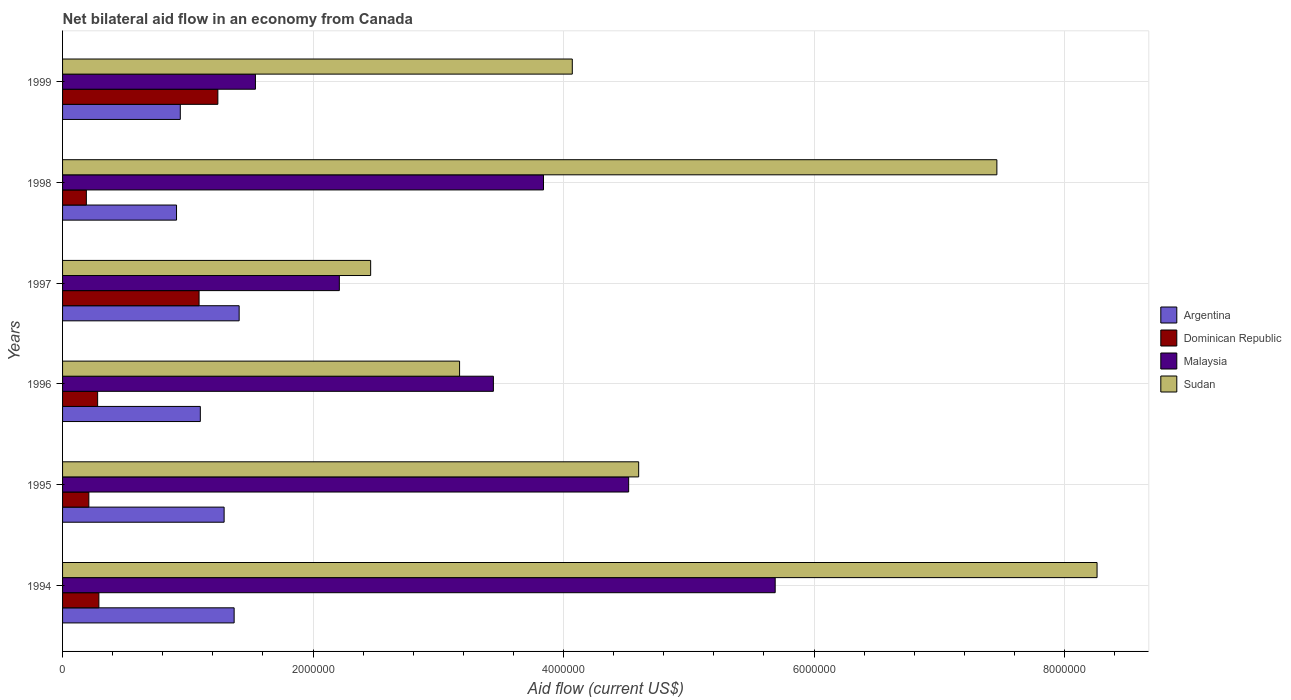How many different coloured bars are there?
Ensure brevity in your answer.  4. How many groups of bars are there?
Provide a succinct answer. 6. Are the number of bars per tick equal to the number of legend labels?
Provide a short and direct response. Yes. What is the label of the 1st group of bars from the top?
Offer a very short reply. 1999. In how many cases, is the number of bars for a given year not equal to the number of legend labels?
Your answer should be very brief. 0. What is the net bilateral aid flow in Malaysia in 1997?
Keep it short and to the point. 2.21e+06. Across all years, what is the maximum net bilateral aid flow in Sudan?
Offer a terse response. 8.26e+06. Across all years, what is the minimum net bilateral aid flow in Argentina?
Your response must be concise. 9.10e+05. What is the total net bilateral aid flow in Argentina in the graph?
Keep it short and to the point. 7.02e+06. What is the difference between the net bilateral aid flow in Malaysia in 1996 and the net bilateral aid flow in Argentina in 1998?
Offer a terse response. 2.53e+06. What is the average net bilateral aid flow in Argentina per year?
Your answer should be very brief. 1.17e+06. In the year 1998, what is the difference between the net bilateral aid flow in Dominican Republic and net bilateral aid flow in Malaysia?
Your answer should be compact. -3.65e+06. In how many years, is the net bilateral aid flow in Sudan greater than 7200000 US$?
Give a very brief answer. 2. What is the ratio of the net bilateral aid flow in Malaysia in 1994 to that in 1998?
Provide a succinct answer. 1.48. What is the difference between the highest and the lowest net bilateral aid flow in Sudan?
Provide a short and direct response. 5.80e+06. Is it the case that in every year, the sum of the net bilateral aid flow in Sudan and net bilateral aid flow in Argentina is greater than the sum of net bilateral aid flow in Malaysia and net bilateral aid flow in Dominican Republic?
Make the answer very short. No. What does the 3rd bar from the top in 1996 represents?
Your response must be concise. Dominican Republic. What does the 2nd bar from the bottom in 1997 represents?
Provide a succinct answer. Dominican Republic. Is it the case that in every year, the sum of the net bilateral aid flow in Sudan and net bilateral aid flow in Dominican Republic is greater than the net bilateral aid flow in Argentina?
Give a very brief answer. Yes. How many bars are there?
Make the answer very short. 24. How many years are there in the graph?
Provide a short and direct response. 6. Does the graph contain any zero values?
Your answer should be very brief. No. How many legend labels are there?
Your answer should be very brief. 4. What is the title of the graph?
Your answer should be very brief. Net bilateral aid flow in an economy from Canada. Does "South Africa" appear as one of the legend labels in the graph?
Ensure brevity in your answer.  No. What is the label or title of the X-axis?
Give a very brief answer. Aid flow (current US$). What is the Aid flow (current US$) in Argentina in 1994?
Your answer should be compact. 1.37e+06. What is the Aid flow (current US$) of Dominican Republic in 1994?
Your answer should be very brief. 2.90e+05. What is the Aid flow (current US$) of Malaysia in 1994?
Offer a very short reply. 5.69e+06. What is the Aid flow (current US$) of Sudan in 1994?
Ensure brevity in your answer.  8.26e+06. What is the Aid flow (current US$) in Argentina in 1995?
Give a very brief answer. 1.29e+06. What is the Aid flow (current US$) of Dominican Republic in 1995?
Offer a terse response. 2.10e+05. What is the Aid flow (current US$) in Malaysia in 1995?
Make the answer very short. 4.52e+06. What is the Aid flow (current US$) of Sudan in 1995?
Ensure brevity in your answer.  4.60e+06. What is the Aid flow (current US$) in Argentina in 1996?
Your response must be concise. 1.10e+06. What is the Aid flow (current US$) of Malaysia in 1996?
Your answer should be very brief. 3.44e+06. What is the Aid flow (current US$) of Sudan in 1996?
Your answer should be very brief. 3.17e+06. What is the Aid flow (current US$) in Argentina in 1997?
Your answer should be compact. 1.41e+06. What is the Aid flow (current US$) in Dominican Republic in 1997?
Your answer should be very brief. 1.09e+06. What is the Aid flow (current US$) in Malaysia in 1997?
Ensure brevity in your answer.  2.21e+06. What is the Aid flow (current US$) of Sudan in 1997?
Your response must be concise. 2.46e+06. What is the Aid flow (current US$) of Argentina in 1998?
Your answer should be compact. 9.10e+05. What is the Aid flow (current US$) in Dominican Republic in 1998?
Your response must be concise. 1.90e+05. What is the Aid flow (current US$) of Malaysia in 1998?
Your response must be concise. 3.84e+06. What is the Aid flow (current US$) of Sudan in 1998?
Keep it short and to the point. 7.46e+06. What is the Aid flow (current US$) in Argentina in 1999?
Keep it short and to the point. 9.40e+05. What is the Aid flow (current US$) of Dominican Republic in 1999?
Your answer should be compact. 1.24e+06. What is the Aid flow (current US$) of Malaysia in 1999?
Provide a succinct answer. 1.54e+06. What is the Aid flow (current US$) in Sudan in 1999?
Give a very brief answer. 4.07e+06. Across all years, what is the maximum Aid flow (current US$) in Argentina?
Give a very brief answer. 1.41e+06. Across all years, what is the maximum Aid flow (current US$) in Dominican Republic?
Provide a short and direct response. 1.24e+06. Across all years, what is the maximum Aid flow (current US$) in Malaysia?
Offer a very short reply. 5.69e+06. Across all years, what is the maximum Aid flow (current US$) in Sudan?
Offer a very short reply. 8.26e+06. Across all years, what is the minimum Aid flow (current US$) of Argentina?
Provide a short and direct response. 9.10e+05. Across all years, what is the minimum Aid flow (current US$) of Malaysia?
Keep it short and to the point. 1.54e+06. Across all years, what is the minimum Aid flow (current US$) in Sudan?
Ensure brevity in your answer.  2.46e+06. What is the total Aid flow (current US$) of Argentina in the graph?
Your answer should be very brief. 7.02e+06. What is the total Aid flow (current US$) of Dominican Republic in the graph?
Provide a short and direct response. 3.30e+06. What is the total Aid flow (current US$) of Malaysia in the graph?
Ensure brevity in your answer.  2.12e+07. What is the total Aid flow (current US$) of Sudan in the graph?
Your answer should be very brief. 3.00e+07. What is the difference between the Aid flow (current US$) in Argentina in 1994 and that in 1995?
Your answer should be compact. 8.00e+04. What is the difference between the Aid flow (current US$) of Dominican Republic in 1994 and that in 1995?
Provide a short and direct response. 8.00e+04. What is the difference between the Aid flow (current US$) in Malaysia in 1994 and that in 1995?
Provide a succinct answer. 1.17e+06. What is the difference between the Aid flow (current US$) in Sudan in 1994 and that in 1995?
Ensure brevity in your answer.  3.66e+06. What is the difference between the Aid flow (current US$) of Malaysia in 1994 and that in 1996?
Your answer should be compact. 2.25e+06. What is the difference between the Aid flow (current US$) in Sudan in 1994 and that in 1996?
Your response must be concise. 5.09e+06. What is the difference between the Aid flow (current US$) of Dominican Republic in 1994 and that in 1997?
Offer a very short reply. -8.00e+05. What is the difference between the Aid flow (current US$) in Malaysia in 1994 and that in 1997?
Your answer should be compact. 3.48e+06. What is the difference between the Aid flow (current US$) of Sudan in 1994 and that in 1997?
Offer a terse response. 5.80e+06. What is the difference between the Aid flow (current US$) of Malaysia in 1994 and that in 1998?
Your response must be concise. 1.85e+06. What is the difference between the Aid flow (current US$) in Sudan in 1994 and that in 1998?
Keep it short and to the point. 8.00e+05. What is the difference between the Aid flow (current US$) in Argentina in 1994 and that in 1999?
Your response must be concise. 4.30e+05. What is the difference between the Aid flow (current US$) in Dominican Republic in 1994 and that in 1999?
Give a very brief answer. -9.50e+05. What is the difference between the Aid flow (current US$) in Malaysia in 1994 and that in 1999?
Your response must be concise. 4.15e+06. What is the difference between the Aid flow (current US$) in Sudan in 1994 and that in 1999?
Keep it short and to the point. 4.19e+06. What is the difference between the Aid flow (current US$) in Dominican Republic in 1995 and that in 1996?
Your response must be concise. -7.00e+04. What is the difference between the Aid flow (current US$) in Malaysia in 1995 and that in 1996?
Provide a short and direct response. 1.08e+06. What is the difference between the Aid flow (current US$) in Sudan in 1995 and that in 1996?
Keep it short and to the point. 1.43e+06. What is the difference between the Aid flow (current US$) in Dominican Republic in 1995 and that in 1997?
Your answer should be compact. -8.80e+05. What is the difference between the Aid flow (current US$) in Malaysia in 1995 and that in 1997?
Make the answer very short. 2.31e+06. What is the difference between the Aid flow (current US$) in Sudan in 1995 and that in 1997?
Your response must be concise. 2.14e+06. What is the difference between the Aid flow (current US$) of Dominican Republic in 1995 and that in 1998?
Your answer should be very brief. 2.00e+04. What is the difference between the Aid flow (current US$) in Malaysia in 1995 and that in 1998?
Give a very brief answer. 6.80e+05. What is the difference between the Aid flow (current US$) of Sudan in 1995 and that in 1998?
Offer a terse response. -2.86e+06. What is the difference between the Aid flow (current US$) of Dominican Republic in 1995 and that in 1999?
Ensure brevity in your answer.  -1.03e+06. What is the difference between the Aid flow (current US$) in Malaysia in 1995 and that in 1999?
Provide a short and direct response. 2.98e+06. What is the difference between the Aid flow (current US$) in Sudan in 1995 and that in 1999?
Make the answer very short. 5.30e+05. What is the difference between the Aid flow (current US$) in Argentina in 1996 and that in 1997?
Make the answer very short. -3.10e+05. What is the difference between the Aid flow (current US$) in Dominican Republic in 1996 and that in 1997?
Your response must be concise. -8.10e+05. What is the difference between the Aid flow (current US$) of Malaysia in 1996 and that in 1997?
Ensure brevity in your answer.  1.23e+06. What is the difference between the Aid flow (current US$) of Sudan in 1996 and that in 1997?
Your answer should be very brief. 7.10e+05. What is the difference between the Aid flow (current US$) of Argentina in 1996 and that in 1998?
Make the answer very short. 1.90e+05. What is the difference between the Aid flow (current US$) in Malaysia in 1996 and that in 1998?
Your answer should be very brief. -4.00e+05. What is the difference between the Aid flow (current US$) in Sudan in 1996 and that in 1998?
Your answer should be compact. -4.29e+06. What is the difference between the Aid flow (current US$) of Argentina in 1996 and that in 1999?
Offer a very short reply. 1.60e+05. What is the difference between the Aid flow (current US$) in Dominican Republic in 1996 and that in 1999?
Keep it short and to the point. -9.60e+05. What is the difference between the Aid flow (current US$) in Malaysia in 1996 and that in 1999?
Keep it short and to the point. 1.90e+06. What is the difference between the Aid flow (current US$) of Sudan in 1996 and that in 1999?
Offer a terse response. -9.00e+05. What is the difference between the Aid flow (current US$) in Argentina in 1997 and that in 1998?
Your answer should be compact. 5.00e+05. What is the difference between the Aid flow (current US$) in Malaysia in 1997 and that in 1998?
Offer a terse response. -1.63e+06. What is the difference between the Aid flow (current US$) of Sudan in 1997 and that in 1998?
Make the answer very short. -5.00e+06. What is the difference between the Aid flow (current US$) in Malaysia in 1997 and that in 1999?
Keep it short and to the point. 6.70e+05. What is the difference between the Aid flow (current US$) in Sudan in 1997 and that in 1999?
Offer a terse response. -1.61e+06. What is the difference between the Aid flow (current US$) of Dominican Republic in 1998 and that in 1999?
Offer a terse response. -1.05e+06. What is the difference between the Aid flow (current US$) of Malaysia in 1998 and that in 1999?
Offer a terse response. 2.30e+06. What is the difference between the Aid flow (current US$) of Sudan in 1998 and that in 1999?
Your response must be concise. 3.39e+06. What is the difference between the Aid flow (current US$) in Argentina in 1994 and the Aid flow (current US$) in Dominican Republic in 1995?
Make the answer very short. 1.16e+06. What is the difference between the Aid flow (current US$) in Argentina in 1994 and the Aid flow (current US$) in Malaysia in 1995?
Your answer should be compact. -3.15e+06. What is the difference between the Aid flow (current US$) in Argentina in 1994 and the Aid flow (current US$) in Sudan in 1995?
Your answer should be very brief. -3.23e+06. What is the difference between the Aid flow (current US$) in Dominican Republic in 1994 and the Aid flow (current US$) in Malaysia in 1995?
Offer a terse response. -4.23e+06. What is the difference between the Aid flow (current US$) of Dominican Republic in 1994 and the Aid flow (current US$) of Sudan in 1995?
Your answer should be compact. -4.31e+06. What is the difference between the Aid flow (current US$) of Malaysia in 1994 and the Aid flow (current US$) of Sudan in 1995?
Provide a short and direct response. 1.09e+06. What is the difference between the Aid flow (current US$) of Argentina in 1994 and the Aid flow (current US$) of Dominican Republic in 1996?
Your answer should be very brief. 1.09e+06. What is the difference between the Aid flow (current US$) in Argentina in 1994 and the Aid flow (current US$) in Malaysia in 1996?
Your answer should be very brief. -2.07e+06. What is the difference between the Aid flow (current US$) of Argentina in 1994 and the Aid flow (current US$) of Sudan in 1996?
Your answer should be compact. -1.80e+06. What is the difference between the Aid flow (current US$) in Dominican Republic in 1994 and the Aid flow (current US$) in Malaysia in 1996?
Your answer should be compact. -3.15e+06. What is the difference between the Aid flow (current US$) in Dominican Republic in 1994 and the Aid flow (current US$) in Sudan in 1996?
Give a very brief answer. -2.88e+06. What is the difference between the Aid flow (current US$) in Malaysia in 1994 and the Aid flow (current US$) in Sudan in 1996?
Offer a terse response. 2.52e+06. What is the difference between the Aid flow (current US$) of Argentina in 1994 and the Aid flow (current US$) of Malaysia in 1997?
Make the answer very short. -8.40e+05. What is the difference between the Aid flow (current US$) in Argentina in 1994 and the Aid flow (current US$) in Sudan in 1997?
Ensure brevity in your answer.  -1.09e+06. What is the difference between the Aid flow (current US$) of Dominican Republic in 1994 and the Aid flow (current US$) of Malaysia in 1997?
Offer a terse response. -1.92e+06. What is the difference between the Aid flow (current US$) in Dominican Republic in 1994 and the Aid flow (current US$) in Sudan in 1997?
Your response must be concise. -2.17e+06. What is the difference between the Aid flow (current US$) of Malaysia in 1994 and the Aid flow (current US$) of Sudan in 1997?
Keep it short and to the point. 3.23e+06. What is the difference between the Aid flow (current US$) in Argentina in 1994 and the Aid flow (current US$) in Dominican Republic in 1998?
Provide a succinct answer. 1.18e+06. What is the difference between the Aid flow (current US$) of Argentina in 1994 and the Aid flow (current US$) of Malaysia in 1998?
Your answer should be very brief. -2.47e+06. What is the difference between the Aid flow (current US$) in Argentina in 1994 and the Aid flow (current US$) in Sudan in 1998?
Keep it short and to the point. -6.09e+06. What is the difference between the Aid flow (current US$) in Dominican Republic in 1994 and the Aid flow (current US$) in Malaysia in 1998?
Your answer should be very brief. -3.55e+06. What is the difference between the Aid flow (current US$) of Dominican Republic in 1994 and the Aid flow (current US$) of Sudan in 1998?
Keep it short and to the point. -7.17e+06. What is the difference between the Aid flow (current US$) of Malaysia in 1994 and the Aid flow (current US$) of Sudan in 1998?
Provide a succinct answer. -1.77e+06. What is the difference between the Aid flow (current US$) in Argentina in 1994 and the Aid flow (current US$) in Dominican Republic in 1999?
Your answer should be very brief. 1.30e+05. What is the difference between the Aid flow (current US$) in Argentina in 1994 and the Aid flow (current US$) in Malaysia in 1999?
Your answer should be very brief. -1.70e+05. What is the difference between the Aid flow (current US$) of Argentina in 1994 and the Aid flow (current US$) of Sudan in 1999?
Offer a very short reply. -2.70e+06. What is the difference between the Aid flow (current US$) of Dominican Republic in 1994 and the Aid flow (current US$) of Malaysia in 1999?
Keep it short and to the point. -1.25e+06. What is the difference between the Aid flow (current US$) in Dominican Republic in 1994 and the Aid flow (current US$) in Sudan in 1999?
Your answer should be compact. -3.78e+06. What is the difference between the Aid flow (current US$) of Malaysia in 1994 and the Aid flow (current US$) of Sudan in 1999?
Provide a short and direct response. 1.62e+06. What is the difference between the Aid flow (current US$) in Argentina in 1995 and the Aid flow (current US$) in Dominican Republic in 1996?
Make the answer very short. 1.01e+06. What is the difference between the Aid flow (current US$) in Argentina in 1995 and the Aid flow (current US$) in Malaysia in 1996?
Provide a short and direct response. -2.15e+06. What is the difference between the Aid flow (current US$) in Argentina in 1995 and the Aid flow (current US$) in Sudan in 1996?
Ensure brevity in your answer.  -1.88e+06. What is the difference between the Aid flow (current US$) of Dominican Republic in 1995 and the Aid flow (current US$) of Malaysia in 1996?
Provide a succinct answer. -3.23e+06. What is the difference between the Aid flow (current US$) of Dominican Republic in 1995 and the Aid flow (current US$) of Sudan in 1996?
Make the answer very short. -2.96e+06. What is the difference between the Aid flow (current US$) in Malaysia in 1995 and the Aid flow (current US$) in Sudan in 1996?
Make the answer very short. 1.35e+06. What is the difference between the Aid flow (current US$) in Argentina in 1995 and the Aid flow (current US$) in Malaysia in 1997?
Ensure brevity in your answer.  -9.20e+05. What is the difference between the Aid flow (current US$) in Argentina in 1995 and the Aid flow (current US$) in Sudan in 1997?
Give a very brief answer. -1.17e+06. What is the difference between the Aid flow (current US$) in Dominican Republic in 1995 and the Aid flow (current US$) in Sudan in 1997?
Your response must be concise. -2.25e+06. What is the difference between the Aid flow (current US$) in Malaysia in 1995 and the Aid flow (current US$) in Sudan in 1997?
Offer a very short reply. 2.06e+06. What is the difference between the Aid flow (current US$) in Argentina in 1995 and the Aid flow (current US$) in Dominican Republic in 1998?
Your answer should be compact. 1.10e+06. What is the difference between the Aid flow (current US$) of Argentina in 1995 and the Aid flow (current US$) of Malaysia in 1998?
Your answer should be very brief. -2.55e+06. What is the difference between the Aid flow (current US$) of Argentina in 1995 and the Aid flow (current US$) of Sudan in 1998?
Provide a succinct answer. -6.17e+06. What is the difference between the Aid flow (current US$) of Dominican Republic in 1995 and the Aid flow (current US$) of Malaysia in 1998?
Offer a terse response. -3.63e+06. What is the difference between the Aid flow (current US$) in Dominican Republic in 1995 and the Aid flow (current US$) in Sudan in 1998?
Provide a short and direct response. -7.25e+06. What is the difference between the Aid flow (current US$) in Malaysia in 1995 and the Aid flow (current US$) in Sudan in 1998?
Offer a very short reply. -2.94e+06. What is the difference between the Aid flow (current US$) of Argentina in 1995 and the Aid flow (current US$) of Malaysia in 1999?
Make the answer very short. -2.50e+05. What is the difference between the Aid flow (current US$) in Argentina in 1995 and the Aid flow (current US$) in Sudan in 1999?
Provide a short and direct response. -2.78e+06. What is the difference between the Aid flow (current US$) of Dominican Republic in 1995 and the Aid flow (current US$) of Malaysia in 1999?
Provide a succinct answer. -1.33e+06. What is the difference between the Aid flow (current US$) in Dominican Republic in 1995 and the Aid flow (current US$) in Sudan in 1999?
Offer a terse response. -3.86e+06. What is the difference between the Aid flow (current US$) in Argentina in 1996 and the Aid flow (current US$) in Malaysia in 1997?
Ensure brevity in your answer.  -1.11e+06. What is the difference between the Aid flow (current US$) of Argentina in 1996 and the Aid flow (current US$) of Sudan in 1997?
Provide a succinct answer. -1.36e+06. What is the difference between the Aid flow (current US$) in Dominican Republic in 1996 and the Aid flow (current US$) in Malaysia in 1997?
Your answer should be very brief. -1.93e+06. What is the difference between the Aid flow (current US$) in Dominican Republic in 1996 and the Aid flow (current US$) in Sudan in 1997?
Your answer should be compact. -2.18e+06. What is the difference between the Aid flow (current US$) of Malaysia in 1996 and the Aid flow (current US$) of Sudan in 1997?
Give a very brief answer. 9.80e+05. What is the difference between the Aid flow (current US$) of Argentina in 1996 and the Aid flow (current US$) of Dominican Republic in 1998?
Your answer should be compact. 9.10e+05. What is the difference between the Aid flow (current US$) in Argentina in 1996 and the Aid flow (current US$) in Malaysia in 1998?
Your answer should be compact. -2.74e+06. What is the difference between the Aid flow (current US$) in Argentina in 1996 and the Aid flow (current US$) in Sudan in 1998?
Ensure brevity in your answer.  -6.36e+06. What is the difference between the Aid flow (current US$) of Dominican Republic in 1996 and the Aid flow (current US$) of Malaysia in 1998?
Provide a short and direct response. -3.56e+06. What is the difference between the Aid flow (current US$) in Dominican Republic in 1996 and the Aid flow (current US$) in Sudan in 1998?
Ensure brevity in your answer.  -7.18e+06. What is the difference between the Aid flow (current US$) of Malaysia in 1996 and the Aid flow (current US$) of Sudan in 1998?
Make the answer very short. -4.02e+06. What is the difference between the Aid flow (current US$) in Argentina in 1996 and the Aid flow (current US$) in Malaysia in 1999?
Give a very brief answer. -4.40e+05. What is the difference between the Aid flow (current US$) of Argentina in 1996 and the Aid flow (current US$) of Sudan in 1999?
Offer a very short reply. -2.97e+06. What is the difference between the Aid flow (current US$) in Dominican Republic in 1996 and the Aid flow (current US$) in Malaysia in 1999?
Provide a succinct answer. -1.26e+06. What is the difference between the Aid flow (current US$) in Dominican Republic in 1996 and the Aid flow (current US$) in Sudan in 1999?
Provide a succinct answer. -3.79e+06. What is the difference between the Aid flow (current US$) in Malaysia in 1996 and the Aid flow (current US$) in Sudan in 1999?
Your response must be concise. -6.30e+05. What is the difference between the Aid flow (current US$) of Argentina in 1997 and the Aid flow (current US$) of Dominican Republic in 1998?
Offer a terse response. 1.22e+06. What is the difference between the Aid flow (current US$) in Argentina in 1997 and the Aid flow (current US$) in Malaysia in 1998?
Keep it short and to the point. -2.43e+06. What is the difference between the Aid flow (current US$) in Argentina in 1997 and the Aid flow (current US$) in Sudan in 1998?
Provide a succinct answer. -6.05e+06. What is the difference between the Aid flow (current US$) in Dominican Republic in 1997 and the Aid flow (current US$) in Malaysia in 1998?
Offer a very short reply. -2.75e+06. What is the difference between the Aid flow (current US$) in Dominican Republic in 1997 and the Aid flow (current US$) in Sudan in 1998?
Provide a short and direct response. -6.37e+06. What is the difference between the Aid flow (current US$) of Malaysia in 1997 and the Aid flow (current US$) of Sudan in 1998?
Make the answer very short. -5.25e+06. What is the difference between the Aid flow (current US$) of Argentina in 1997 and the Aid flow (current US$) of Sudan in 1999?
Ensure brevity in your answer.  -2.66e+06. What is the difference between the Aid flow (current US$) of Dominican Republic in 1997 and the Aid flow (current US$) of Malaysia in 1999?
Make the answer very short. -4.50e+05. What is the difference between the Aid flow (current US$) of Dominican Republic in 1997 and the Aid flow (current US$) of Sudan in 1999?
Your response must be concise. -2.98e+06. What is the difference between the Aid flow (current US$) of Malaysia in 1997 and the Aid flow (current US$) of Sudan in 1999?
Your answer should be very brief. -1.86e+06. What is the difference between the Aid flow (current US$) of Argentina in 1998 and the Aid flow (current US$) of Dominican Republic in 1999?
Provide a succinct answer. -3.30e+05. What is the difference between the Aid flow (current US$) of Argentina in 1998 and the Aid flow (current US$) of Malaysia in 1999?
Your answer should be compact. -6.30e+05. What is the difference between the Aid flow (current US$) of Argentina in 1998 and the Aid flow (current US$) of Sudan in 1999?
Your response must be concise. -3.16e+06. What is the difference between the Aid flow (current US$) in Dominican Republic in 1998 and the Aid flow (current US$) in Malaysia in 1999?
Offer a very short reply. -1.35e+06. What is the difference between the Aid flow (current US$) of Dominican Republic in 1998 and the Aid flow (current US$) of Sudan in 1999?
Ensure brevity in your answer.  -3.88e+06. What is the difference between the Aid flow (current US$) in Malaysia in 1998 and the Aid flow (current US$) in Sudan in 1999?
Offer a terse response. -2.30e+05. What is the average Aid flow (current US$) of Argentina per year?
Your response must be concise. 1.17e+06. What is the average Aid flow (current US$) in Malaysia per year?
Your answer should be compact. 3.54e+06. What is the average Aid flow (current US$) in Sudan per year?
Your answer should be very brief. 5.00e+06. In the year 1994, what is the difference between the Aid flow (current US$) in Argentina and Aid flow (current US$) in Dominican Republic?
Provide a succinct answer. 1.08e+06. In the year 1994, what is the difference between the Aid flow (current US$) of Argentina and Aid flow (current US$) of Malaysia?
Provide a succinct answer. -4.32e+06. In the year 1994, what is the difference between the Aid flow (current US$) of Argentina and Aid flow (current US$) of Sudan?
Offer a very short reply. -6.89e+06. In the year 1994, what is the difference between the Aid flow (current US$) of Dominican Republic and Aid flow (current US$) of Malaysia?
Provide a short and direct response. -5.40e+06. In the year 1994, what is the difference between the Aid flow (current US$) of Dominican Republic and Aid flow (current US$) of Sudan?
Offer a very short reply. -7.97e+06. In the year 1994, what is the difference between the Aid flow (current US$) of Malaysia and Aid flow (current US$) of Sudan?
Your answer should be very brief. -2.57e+06. In the year 1995, what is the difference between the Aid flow (current US$) of Argentina and Aid flow (current US$) of Dominican Republic?
Keep it short and to the point. 1.08e+06. In the year 1995, what is the difference between the Aid flow (current US$) of Argentina and Aid flow (current US$) of Malaysia?
Keep it short and to the point. -3.23e+06. In the year 1995, what is the difference between the Aid flow (current US$) of Argentina and Aid flow (current US$) of Sudan?
Make the answer very short. -3.31e+06. In the year 1995, what is the difference between the Aid flow (current US$) of Dominican Republic and Aid flow (current US$) of Malaysia?
Offer a terse response. -4.31e+06. In the year 1995, what is the difference between the Aid flow (current US$) of Dominican Republic and Aid flow (current US$) of Sudan?
Ensure brevity in your answer.  -4.39e+06. In the year 1995, what is the difference between the Aid flow (current US$) in Malaysia and Aid flow (current US$) in Sudan?
Make the answer very short. -8.00e+04. In the year 1996, what is the difference between the Aid flow (current US$) in Argentina and Aid flow (current US$) in Dominican Republic?
Ensure brevity in your answer.  8.20e+05. In the year 1996, what is the difference between the Aid flow (current US$) of Argentina and Aid flow (current US$) of Malaysia?
Your answer should be very brief. -2.34e+06. In the year 1996, what is the difference between the Aid flow (current US$) in Argentina and Aid flow (current US$) in Sudan?
Your answer should be compact. -2.07e+06. In the year 1996, what is the difference between the Aid flow (current US$) of Dominican Republic and Aid flow (current US$) of Malaysia?
Give a very brief answer. -3.16e+06. In the year 1996, what is the difference between the Aid flow (current US$) in Dominican Republic and Aid flow (current US$) in Sudan?
Ensure brevity in your answer.  -2.89e+06. In the year 1996, what is the difference between the Aid flow (current US$) in Malaysia and Aid flow (current US$) in Sudan?
Give a very brief answer. 2.70e+05. In the year 1997, what is the difference between the Aid flow (current US$) of Argentina and Aid flow (current US$) of Dominican Republic?
Ensure brevity in your answer.  3.20e+05. In the year 1997, what is the difference between the Aid flow (current US$) of Argentina and Aid flow (current US$) of Malaysia?
Give a very brief answer. -8.00e+05. In the year 1997, what is the difference between the Aid flow (current US$) in Argentina and Aid flow (current US$) in Sudan?
Keep it short and to the point. -1.05e+06. In the year 1997, what is the difference between the Aid flow (current US$) of Dominican Republic and Aid flow (current US$) of Malaysia?
Ensure brevity in your answer.  -1.12e+06. In the year 1997, what is the difference between the Aid flow (current US$) in Dominican Republic and Aid flow (current US$) in Sudan?
Your response must be concise. -1.37e+06. In the year 1998, what is the difference between the Aid flow (current US$) in Argentina and Aid flow (current US$) in Dominican Republic?
Keep it short and to the point. 7.20e+05. In the year 1998, what is the difference between the Aid flow (current US$) in Argentina and Aid flow (current US$) in Malaysia?
Provide a short and direct response. -2.93e+06. In the year 1998, what is the difference between the Aid flow (current US$) of Argentina and Aid flow (current US$) of Sudan?
Offer a terse response. -6.55e+06. In the year 1998, what is the difference between the Aid flow (current US$) of Dominican Republic and Aid flow (current US$) of Malaysia?
Ensure brevity in your answer.  -3.65e+06. In the year 1998, what is the difference between the Aid flow (current US$) in Dominican Republic and Aid flow (current US$) in Sudan?
Offer a terse response. -7.27e+06. In the year 1998, what is the difference between the Aid flow (current US$) of Malaysia and Aid flow (current US$) of Sudan?
Offer a terse response. -3.62e+06. In the year 1999, what is the difference between the Aid flow (current US$) of Argentina and Aid flow (current US$) of Malaysia?
Provide a short and direct response. -6.00e+05. In the year 1999, what is the difference between the Aid flow (current US$) in Argentina and Aid flow (current US$) in Sudan?
Make the answer very short. -3.13e+06. In the year 1999, what is the difference between the Aid flow (current US$) in Dominican Republic and Aid flow (current US$) in Sudan?
Your answer should be compact. -2.83e+06. In the year 1999, what is the difference between the Aid flow (current US$) of Malaysia and Aid flow (current US$) of Sudan?
Your response must be concise. -2.53e+06. What is the ratio of the Aid flow (current US$) of Argentina in 1994 to that in 1995?
Ensure brevity in your answer.  1.06. What is the ratio of the Aid flow (current US$) of Dominican Republic in 1994 to that in 1995?
Provide a succinct answer. 1.38. What is the ratio of the Aid flow (current US$) in Malaysia in 1994 to that in 1995?
Ensure brevity in your answer.  1.26. What is the ratio of the Aid flow (current US$) of Sudan in 1994 to that in 1995?
Ensure brevity in your answer.  1.8. What is the ratio of the Aid flow (current US$) of Argentina in 1994 to that in 1996?
Provide a succinct answer. 1.25. What is the ratio of the Aid flow (current US$) in Dominican Republic in 1994 to that in 1996?
Your answer should be very brief. 1.04. What is the ratio of the Aid flow (current US$) of Malaysia in 1994 to that in 1996?
Your response must be concise. 1.65. What is the ratio of the Aid flow (current US$) in Sudan in 1994 to that in 1996?
Offer a terse response. 2.61. What is the ratio of the Aid flow (current US$) in Argentina in 1994 to that in 1997?
Ensure brevity in your answer.  0.97. What is the ratio of the Aid flow (current US$) in Dominican Republic in 1994 to that in 1997?
Provide a short and direct response. 0.27. What is the ratio of the Aid flow (current US$) in Malaysia in 1994 to that in 1997?
Offer a terse response. 2.57. What is the ratio of the Aid flow (current US$) in Sudan in 1994 to that in 1997?
Your answer should be very brief. 3.36. What is the ratio of the Aid flow (current US$) of Argentina in 1994 to that in 1998?
Provide a succinct answer. 1.51. What is the ratio of the Aid flow (current US$) of Dominican Republic in 1994 to that in 1998?
Ensure brevity in your answer.  1.53. What is the ratio of the Aid flow (current US$) of Malaysia in 1994 to that in 1998?
Ensure brevity in your answer.  1.48. What is the ratio of the Aid flow (current US$) of Sudan in 1994 to that in 1998?
Your answer should be compact. 1.11. What is the ratio of the Aid flow (current US$) in Argentina in 1994 to that in 1999?
Your answer should be compact. 1.46. What is the ratio of the Aid flow (current US$) of Dominican Republic in 1994 to that in 1999?
Your response must be concise. 0.23. What is the ratio of the Aid flow (current US$) of Malaysia in 1994 to that in 1999?
Keep it short and to the point. 3.69. What is the ratio of the Aid flow (current US$) in Sudan in 1994 to that in 1999?
Provide a succinct answer. 2.03. What is the ratio of the Aid flow (current US$) of Argentina in 1995 to that in 1996?
Make the answer very short. 1.17. What is the ratio of the Aid flow (current US$) in Dominican Republic in 1995 to that in 1996?
Your answer should be compact. 0.75. What is the ratio of the Aid flow (current US$) in Malaysia in 1995 to that in 1996?
Make the answer very short. 1.31. What is the ratio of the Aid flow (current US$) of Sudan in 1995 to that in 1996?
Your answer should be very brief. 1.45. What is the ratio of the Aid flow (current US$) of Argentina in 1995 to that in 1997?
Your response must be concise. 0.91. What is the ratio of the Aid flow (current US$) in Dominican Republic in 1995 to that in 1997?
Your response must be concise. 0.19. What is the ratio of the Aid flow (current US$) in Malaysia in 1995 to that in 1997?
Make the answer very short. 2.05. What is the ratio of the Aid flow (current US$) of Sudan in 1995 to that in 1997?
Offer a very short reply. 1.87. What is the ratio of the Aid flow (current US$) of Argentina in 1995 to that in 1998?
Keep it short and to the point. 1.42. What is the ratio of the Aid flow (current US$) in Dominican Republic in 1995 to that in 1998?
Your response must be concise. 1.11. What is the ratio of the Aid flow (current US$) in Malaysia in 1995 to that in 1998?
Ensure brevity in your answer.  1.18. What is the ratio of the Aid flow (current US$) in Sudan in 1995 to that in 1998?
Provide a short and direct response. 0.62. What is the ratio of the Aid flow (current US$) in Argentina in 1995 to that in 1999?
Your answer should be very brief. 1.37. What is the ratio of the Aid flow (current US$) of Dominican Republic in 1995 to that in 1999?
Your response must be concise. 0.17. What is the ratio of the Aid flow (current US$) of Malaysia in 1995 to that in 1999?
Offer a terse response. 2.94. What is the ratio of the Aid flow (current US$) in Sudan in 1995 to that in 1999?
Your answer should be very brief. 1.13. What is the ratio of the Aid flow (current US$) in Argentina in 1996 to that in 1997?
Keep it short and to the point. 0.78. What is the ratio of the Aid flow (current US$) in Dominican Republic in 1996 to that in 1997?
Ensure brevity in your answer.  0.26. What is the ratio of the Aid flow (current US$) in Malaysia in 1996 to that in 1997?
Keep it short and to the point. 1.56. What is the ratio of the Aid flow (current US$) of Sudan in 1996 to that in 1997?
Provide a succinct answer. 1.29. What is the ratio of the Aid flow (current US$) in Argentina in 1996 to that in 1998?
Ensure brevity in your answer.  1.21. What is the ratio of the Aid flow (current US$) of Dominican Republic in 1996 to that in 1998?
Offer a very short reply. 1.47. What is the ratio of the Aid flow (current US$) of Malaysia in 1996 to that in 1998?
Provide a succinct answer. 0.9. What is the ratio of the Aid flow (current US$) of Sudan in 1996 to that in 1998?
Provide a succinct answer. 0.42. What is the ratio of the Aid flow (current US$) of Argentina in 1996 to that in 1999?
Your response must be concise. 1.17. What is the ratio of the Aid flow (current US$) of Dominican Republic in 1996 to that in 1999?
Provide a succinct answer. 0.23. What is the ratio of the Aid flow (current US$) of Malaysia in 1996 to that in 1999?
Offer a very short reply. 2.23. What is the ratio of the Aid flow (current US$) of Sudan in 1996 to that in 1999?
Offer a terse response. 0.78. What is the ratio of the Aid flow (current US$) in Argentina in 1997 to that in 1998?
Ensure brevity in your answer.  1.55. What is the ratio of the Aid flow (current US$) in Dominican Republic in 1997 to that in 1998?
Make the answer very short. 5.74. What is the ratio of the Aid flow (current US$) of Malaysia in 1997 to that in 1998?
Provide a short and direct response. 0.58. What is the ratio of the Aid flow (current US$) of Sudan in 1997 to that in 1998?
Give a very brief answer. 0.33. What is the ratio of the Aid flow (current US$) of Dominican Republic in 1997 to that in 1999?
Offer a terse response. 0.88. What is the ratio of the Aid flow (current US$) in Malaysia in 1997 to that in 1999?
Ensure brevity in your answer.  1.44. What is the ratio of the Aid flow (current US$) in Sudan in 1997 to that in 1999?
Give a very brief answer. 0.6. What is the ratio of the Aid flow (current US$) of Argentina in 1998 to that in 1999?
Ensure brevity in your answer.  0.97. What is the ratio of the Aid flow (current US$) of Dominican Republic in 1998 to that in 1999?
Your answer should be very brief. 0.15. What is the ratio of the Aid flow (current US$) in Malaysia in 1998 to that in 1999?
Ensure brevity in your answer.  2.49. What is the ratio of the Aid flow (current US$) of Sudan in 1998 to that in 1999?
Offer a very short reply. 1.83. What is the difference between the highest and the second highest Aid flow (current US$) of Argentina?
Provide a succinct answer. 4.00e+04. What is the difference between the highest and the second highest Aid flow (current US$) of Dominican Republic?
Your response must be concise. 1.50e+05. What is the difference between the highest and the second highest Aid flow (current US$) in Malaysia?
Ensure brevity in your answer.  1.17e+06. What is the difference between the highest and the lowest Aid flow (current US$) in Argentina?
Ensure brevity in your answer.  5.00e+05. What is the difference between the highest and the lowest Aid flow (current US$) of Dominican Republic?
Your response must be concise. 1.05e+06. What is the difference between the highest and the lowest Aid flow (current US$) of Malaysia?
Offer a terse response. 4.15e+06. What is the difference between the highest and the lowest Aid flow (current US$) in Sudan?
Offer a terse response. 5.80e+06. 